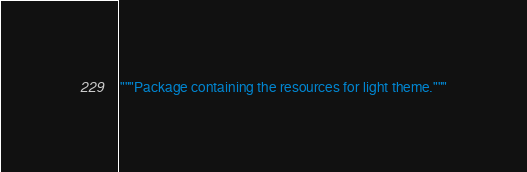Convert code to text. <code><loc_0><loc_0><loc_500><loc_500><_Python_>"""Package containing the resources for light theme."""
</code> 